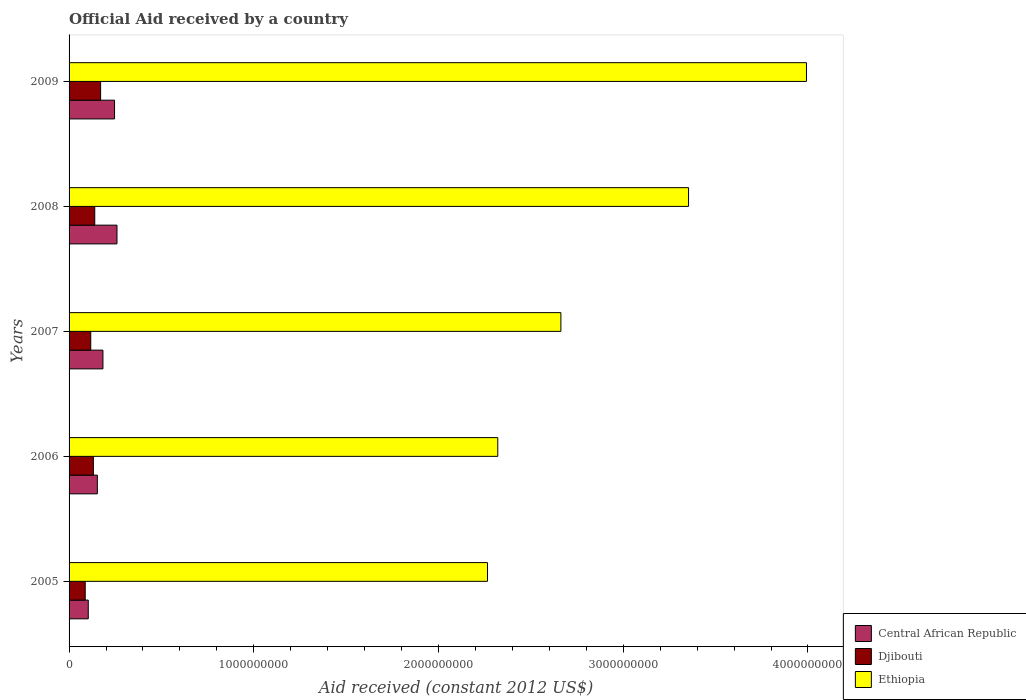Are the number of bars per tick equal to the number of legend labels?
Provide a succinct answer. Yes. How many bars are there on the 3rd tick from the top?
Your answer should be very brief. 3. In how many cases, is the number of bars for a given year not equal to the number of legend labels?
Ensure brevity in your answer.  0. What is the net official aid received in Ethiopia in 2006?
Your response must be concise. 2.32e+09. Across all years, what is the maximum net official aid received in Djibouti?
Keep it short and to the point. 1.71e+08. Across all years, what is the minimum net official aid received in Central African Republic?
Give a very brief answer. 1.04e+08. What is the total net official aid received in Central African Republic in the graph?
Offer a terse response. 9.46e+08. What is the difference between the net official aid received in Djibouti in 2007 and that in 2009?
Provide a succinct answer. -5.34e+07. What is the difference between the net official aid received in Djibouti in 2009 and the net official aid received in Central African Republic in 2007?
Offer a very short reply. -1.25e+07. What is the average net official aid received in Ethiopia per year?
Keep it short and to the point. 2.92e+09. In the year 2008, what is the difference between the net official aid received in Djibouti and net official aid received in Ethiopia?
Offer a very short reply. -3.21e+09. What is the ratio of the net official aid received in Ethiopia in 2007 to that in 2008?
Make the answer very short. 0.79. Is the net official aid received in Ethiopia in 2007 less than that in 2008?
Offer a terse response. Yes. Is the difference between the net official aid received in Djibouti in 2005 and 2008 greater than the difference between the net official aid received in Ethiopia in 2005 and 2008?
Offer a terse response. Yes. What is the difference between the highest and the second highest net official aid received in Ethiopia?
Keep it short and to the point. 6.38e+08. What is the difference between the highest and the lowest net official aid received in Djibouti?
Make the answer very short. 8.34e+07. What does the 3rd bar from the top in 2008 represents?
Your answer should be very brief. Central African Republic. What does the 1st bar from the bottom in 2009 represents?
Provide a succinct answer. Central African Republic. Is it the case that in every year, the sum of the net official aid received in Central African Republic and net official aid received in Ethiopia is greater than the net official aid received in Djibouti?
Provide a succinct answer. Yes. Are all the bars in the graph horizontal?
Offer a very short reply. Yes. Are the values on the major ticks of X-axis written in scientific E-notation?
Your response must be concise. No. Does the graph contain any zero values?
Offer a terse response. No. Does the graph contain grids?
Offer a terse response. No. What is the title of the graph?
Your answer should be compact. Official Aid received by a country. Does "Northern Mariana Islands" appear as one of the legend labels in the graph?
Offer a terse response. No. What is the label or title of the X-axis?
Provide a short and direct response. Aid received (constant 2012 US$). What is the label or title of the Y-axis?
Offer a terse response. Years. What is the Aid received (constant 2012 US$) of Central African Republic in 2005?
Provide a succinct answer. 1.04e+08. What is the Aid received (constant 2012 US$) of Djibouti in 2005?
Give a very brief answer. 8.74e+07. What is the Aid received (constant 2012 US$) of Ethiopia in 2005?
Offer a terse response. 2.27e+09. What is the Aid received (constant 2012 US$) in Central African Republic in 2006?
Provide a short and direct response. 1.53e+08. What is the Aid received (constant 2012 US$) of Djibouti in 2006?
Your response must be concise. 1.32e+08. What is the Aid received (constant 2012 US$) in Ethiopia in 2006?
Your answer should be compact. 2.32e+09. What is the Aid received (constant 2012 US$) of Central African Republic in 2007?
Your response must be concise. 1.83e+08. What is the Aid received (constant 2012 US$) in Djibouti in 2007?
Offer a terse response. 1.17e+08. What is the Aid received (constant 2012 US$) in Ethiopia in 2007?
Your response must be concise. 2.66e+09. What is the Aid received (constant 2012 US$) of Central African Republic in 2008?
Give a very brief answer. 2.59e+08. What is the Aid received (constant 2012 US$) in Djibouti in 2008?
Offer a terse response. 1.39e+08. What is the Aid received (constant 2012 US$) of Ethiopia in 2008?
Your answer should be compact. 3.35e+09. What is the Aid received (constant 2012 US$) in Central African Republic in 2009?
Give a very brief answer. 2.46e+08. What is the Aid received (constant 2012 US$) of Djibouti in 2009?
Offer a terse response. 1.71e+08. What is the Aid received (constant 2012 US$) in Ethiopia in 2009?
Provide a succinct answer. 3.99e+09. Across all years, what is the maximum Aid received (constant 2012 US$) of Central African Republic?
Provide a succinct answer. 2.59e+08. Across all years, what is the maximum Aid received (constant 2012 US$) in Djibouti?
Make the answer very short. 1.71e+08. Across all years, what is the maximum Aid received (constant 2012 US$) in Ethiopia?
Provide a succinct answer. 3.99e+09. Across all years, what is the minimum Aid received (constant 2012 US$) in Central African Republic?
Your answer should be compact. 1.04e+08. Across all years, what is the minimum Aid received (constant 2012 US$) of Djibouti?
Give a very brief answer. 8.74e+07. Across all years, what is the minimum Aid received (constant 2012 US$) of Ethiopia?
Your response must be concise. 2.27e+09. What is the total Aid received (constant 2012 US$) of Central African Republic in the graph?
Your response must be concise. 9.46e+08. What is the total Aid received (constant 2012 US$) in Djibouti in the graph?
Keep it short and to the point. 6.46e+08. What is the total Aid received (constant 2012 US$) in Ethiopia in the graph?
Give a very brief answer. 1.46e+1. What is the difference between the Aid received (constant 2012 US$) of Central African Republic in 2005 and that in 2006?
Offer a terse response. -4.91e+07. What is the difference between the Aid received (constant 2012 US$) in Djibouti in 2005 and that in 2006?
Your answer should be compact. -4.42e+07. What is the difference between the Aid received (constant 2012 US$) in Ethiopia in 2005 and that in 2006?
Provide a short and direct response. -5.56e+07. What is the difference between the Aid received (constant 2012 US$) in Central African Republic in 2005 and that in 2007?
Offer a terse response. -7.94e+07. What is the difference between the Aid received (constant 2012 US$) of Djibouti in 2005 and that in 2007?
Give a very brief answer. -3.00e+07. What is the difference between the Aid received (constant 2012 US$) of Ethiopia in 2005 and that in 2007?
Ensure brevity in your answer.  -3.97e+08. What is the difference between the Aid received (constant 2012 US$) in Central African Republic in 2005 and that in 2008?
Keep it short and to the point. -1.55e+08. What is the difference between the Aid received (constant 2012 US$) in Djibouti in 2005 and that in 2008?
Ensure brevity in your answer.  -5.16e+07. What is the difference between the Aid received (constant 2012 US$) of Ethiopia in 2005 and that in 2008?
Provide a succinct answer. -1.09e+09. What is the difference between the Aid received (constant 2012 US$) of Central African Republic in 2005 and that in 2009?
Your answer should be very brief. -1.42e+08. What is the difference between the Aid received (constant 2012 US$) of Djibouti in 2005 and that in 2009?
Keep it short and to the point. -8.34e+07. What is the difference between the Aid received (constant 2012 US$) of Ethiopia in 2005 and that in 2009?
Offer a very short reply. -1.73e+09. What is the difference between the Aid received (constant 2012 US$) in Central African Republic in 2006 and that in 2007?
Provide a short and direct response. -3.03e+07. What is the difference between the Aid received (constant 2012 US$) in Djibouti in 2006 and that in 2007?
Keep it short and to the point. 1.42e+07. What is the difference between the Aid received (constant 2012 US$) in Ethiopia in 2006 and that in 2007?
Make the answer very short. -3.42e+08. What is the difference between the Aid received (constant 2012 US$) of Central African Republic in 2006 and that in 2008?
Provide a succinct answer. -1.06e+08. What is the difference between the Aid received (constant 2012 US$) of Djibouti in 2006 and that in 2008?
Your answer should be very brief. -7.46e+06. What is the difference between the Aid received (constant 2012 US$) of Ethiopia in 2006 and that in 2008?
Provide a succinct answer. -1.03e+09. What is the difference between the Aid received (constant 2012 US$) of Central African Republic in 2006 and that in 2009?
Your answer should be very brief. -9.32e+07. What is the difference between the Aid received (constant 2012 US$) in Djibouti in 2006 and that in 2009?
Give a very brief answer. -3.92e+07. What is the difference between the Aid received (constant 2012 US$) of Ethiopia in 2006 and that in 2009?
Your answer should be very brief. -1.67e+09. What is the difference between the Aid received (constant 2012 US$) in Central African Republic in 2007 and that in 2008?
Keep it short and to the point. -7.61e+07. What is the difference between the Aid received (constant 2012 US$) of Djibouti in 2007 and that in 2008?
Keep it short and to the point. -2.16e+07. What is the difference between the Aid received (constant 2012 US$) of Ethiopia in 2007 and that in 2008?
Make the answer very short. -6.91e+08. What is the difference between the Aid received (constant 2012 US$) of Central African Republic in 2007 and that in 2009?
Offer a terse response. -6.29e+07. What is the difference between the Aid received (constant 2012 US$) in Djibouti in 2007 and that in 2009?
Offer a very short reply. -5.34e+07. What is the difference between the Aid received (constant 2012 US$) in Ethiopia in 2007 and that in 2009?
Ensure brevity in your answer.  -1.33e+09. What is the difference between the Aid received (constant 2012 US$) in Central African Republic in 2008 and that in 2009?
Offer a terse response. 1.32e+07. What is the difference between the Aid received (constant 2012 US$) in Djibouti in 2008 and that in 2009?
Keep it short and to the point. -3.17e+07. What is the difference between the Aid received (constant 2012 US$) of Ethiopia in 2008 and that in 2009?
Your response must be concise. -6.38e+08. What is the difference between the Aid received (constant 2012 US$) in Central African Republic in 2005 and the Aid received (constant 2012 US$) in Djibouti in 2006?
Ensure brevity in your answer.  -2.76e+07. What is the difference between the Aid received (constant 2012 US$) of Central African Republic in 2005 and the Aid received (constant 2012 US$) of Ethiopia in 2006?
Your response must be concise. -2.22e+09. What is the difference between the Aid received (constant 2012 US$) in Djibouti in 2005 and the Aid received (constant 2012 US$) in Ethiopia in 2006?
Offer a very short reply. -2.23e+09. What is the difference between the Aid received (constant 2012 US$) of Central African Republic in 2005 and the Aid received (constant 2012 US$) of Djibouti in 2007?
Offer a terse response. -1.34e+07. What is the difference between the Aid received (constant 2012 US$) in Central African Republic in 2005 and the Aid received (constant 2012 US$) in Ethiopia in 2007?
Provide a short and direct response. -2.56e+09. What is the difference between the Aid received (constant 2012 US$) of Djibouti in 2005 and the Aid received (constant 2012 US$) of Ethiopia in 2007?
Your response must be concise. -2.58e+09. What is the difference between the Aid received (constant 2012 US$) in Central African Republic in 2005 and the Aid received (constant 2012 US$) in Djibouti in 2008?
Ensure brevity in your answer.  -3.51e+07. What is the difference between the Aid received (constant 2012 US$) of Central African Republic in 2005 and the Aid received (constant 2012 US$) of Ethiopia in 2008?
Your answer should be compact. -3.25e+09. What is the difference between the Aid received (constant 2012 US$) of Djibouti in 2005 and the Aid received (constant 2012 US$) of Ethiopia in 2008?
Provide a succinct answer. -3.27e+09. What is the difference between the Aid received (constant 2012 US$) of Central African Republic in 2005 and the Aid received (constant 2012 US$) of Djibouti in 2009?
Your answer should be very brief. -6.68e+07. What is the difference between the Aid received (constant 2012 US$) in Central African Republic in 2005 and the Aid received (constant 2012 US$) in Ethiopia in 2009?
Provide a succinct answer. -3.89e+09. What is the difference between the Aid received (constant 2012 US$) of Djibouti in 2005 and the Aid received (constant 2012 US$) of Ethiopia in 2009?
Provide a succinct answer. -3.90e+09. What is the difference between the Aid received (constant 2012 US$) of Central African Republic in 2006 and the Aid received (constant 2012 US$) of Djibouti in 2007?
Provide a short and direct response. 3.56e+07. What is the difference between the Aid received (constant 2012 US$) of Central African Republic in 2006 and the Aid received (constant 2012 US$) of Ethiopia in 2007?
Provide a short and direct response. -2.51e+09. What is the difference between the Aid received (constant 2012 US$) of Djibouti in 2006 and the Aid received (constant 2012 US$) of Ethiopia in 2007?
Your response must be concise. -2.53e+09. What is the difference between the Aid received (constant 2012 US$) of Central African Republic in 2006 and the Aid received (constant 2012 US$) of Djibouti in 2008?
Your answer should be compact. 1.40e+07. What is the difference between the Aid received (constant 2012 US$) of Central African Republic in 2006 and the Aid received (constant 2012 US$) of Ethiopia in 2008?
Make the answer very short. -3.20e+09. What is the difference between the Aid received (constant 2012 US$) in Djibouti in 2006 and the Aid received (constant 2012 US$) in Ethiopia in 2008?
Keep it short and to the point. -3.22e+09. What is the difference between the Aid received (constant 2012 US$) in Central African Republic in 2006 and the Aid received (constant 2012 US$) in Djibouti in 2009?
Provide a succinct answer. -1.78e+07. What is the difference between the Aid received (constant 2012 US$) in Central African Republic in 2006 and the Aid received (constant 2012 US$) in Ethiopia in 2009?
Keep it short and to the point. -3.84e+09. What is the difference between the Aid received (constant 2012 US$) in Djibouti in 2006 and the Aid received (constant 2012 US$) in Ethiopia in 2009?
Make the answer very short. -3.86e+09. What is the difference between the Aid received (constant 2012 US$) of Central African Republic in 2007 and the Aid received (constant 2012 US$) of Djibouti in 2008?
Your answer should be compact. 4.43e+07. What is the difference between the Aid received (constant 2012 US$) of Central African Republic in 2007 and the Aid received (constant 2012 US$) of Ethiopia in 2008?
Keep it short and to the point. -3.17e+09. What is the difference between the Aid received (constant 2012 US$) of Djibouti in 2007 and the Aid received (constant 2012 US$) of Ethiopia in 2008?
Offer a terse response. -3.24e+09. What is the difference between the Aid received (constant 2012 US$) in Central African Republic in 2007 and the Aid received (constant 2012 US$) in Djibouti in 2009?
Offer a terse response. 1.25e+07. What is the difference between the Aid received (constant 2012 US$) of Central African Republic in 2007 and the Aid received (constant 2012 US$) of Ethiopia in 2009?
Ensure brevity in your answer.  -3.81e+09. What is the difference between the Aid received (constant 2012 US$) of Djibouti in 2007 and the Aid received (constant 2012 US$) of Ethiopia in 2009?
Offer a very short reply. -3.87e+09. What is the difference between the Aid received (constant 2012 US$) of Central African Republic in 2008 and the Aid received (constant 2012 US$) of Djibouti in 2009?
Make the answer very short. 8.86e+07. What is the difference between the Aid received (constant 2012 US$) in Central African Republic in 2008 and the Aid received (constant 2012 US$) in Ethiopia in 2009?
Your response must be concise. -3.73e+09. What is the difference between the Aid received (constant 2012 US$) of Djibouti in 2008 and the Aid received (constant 2012 US$) of Ethiopia in 2009?
Keep it short and to the point. -3.85e+09. What is the average Aid received (constant 2012 US$) in Central African Republic per year?
Ensure brevity in your answer.  1.89e+08. What is the average Aid received (constant 2012 US$) of Djibouti per year?
Your response must be concise. 1.29e+08. What is the average Aid received (constant 2012 US$) of Ethiopia per year?
Give a very brief answer. 2.92e+09. In the year 2005, what is the difference between the Aid received (constant 2012 US$) of Central African Republic and Aid received (constant 2012 US$) of Djibouti?
Ensure brevity in your answer.  1.66e+07. In the year 2005, what is the difference between the Aid received (constant 2012 US$) of Central African Republic and Aid received (constant 2012 US$) of Ethiopia?
Ensure brevity in your answer.  -2.16e+09. In the year 2005, what is the difference between the Aid received (constant 2012 US$) of Djibouti and Aid received (constant 2012 US$) of Ethiopia?
Your answer should be very brief. -2.18e+09. In the year 2006, what is the difference between the Aid received (constant 2012 US$) of Central African Republic and Aid received (constant 2012 US$) of Djibouti?
Your answer should be very brief. 2.14e+07. In the year 2006, what is the difference between the Aid received (constant 2012 US$) of Central African Republic and Aid received (constant 2012 US$) of Ethiopia?
Offer a terse response. -2.17e+09. In the year 2006, what is the difference between the Aid received (constant 2012 US$) of Djibouti and Aid received (constant 2012 US$) of Ethiopia?
Offer a very short reply. -2.19e+09. In the year 2007, what is the difference between the Aid received (constant 2012 US$) of Central African Republic and Aid received (constant 2012 US$) of Djibouti?
Provide a short and direct response. 6.59e+07. In the year 2007, what is the difference between the Aid received (constant 2012 US$) in Central African Republic and Aid received (constant 2012 US$) in Ethiopia?
Your answer should be very brief. -2.48e+09. In the year 2007, what is the difference between the Aid received (constant 2012 US$) of Djibouti and Aid received (constant 2012 US$) of Ethiopia?
Provide a short and direct response. -2.55e+09. In the year 2008, what is the difference between the Aid received (constant 2012 US$) of Central African Republic and Aid received (constant 2012 US$) of Djibouti?
Provide a short and direct response. 1.20e+08. In the year 2008, what is the difference between the Aid received (constant 2012 US$) of Central African Republic and Aid received (constant 2012 US$) of Ethiopia?
Your response must be concise. -3.09e+09. In the year 2008, what is the difference between the Aid received (constant 2012 US$) in Djibouti and Aid received (constant 2012 US$) in Ethiopia?
Your response must be concise. -3.21e+09. In the year 2009, what is the difference between the Aid received (constant 2012 US$) of Central African Republic and Aid received (constant 2012 US$) of Djibouti?
Offer a very short reply. 7.54e+07. In the year 2009, what is the difference between the Aid received (constant 2012 US$) of Central African Republic and Aid received (constant 2012 US$) of Ethiopia?
Your answer should be compact. -3.75e+09. In the year 2009, what is the difference between the Aid received (constant 2012 US$) in Djibouti and Aid received (constant 2012 US$) in Ethiopia?
Provide a short and direct response. -3.82e+09. What is the ratio of the Aid received (constant 2012 US$) in Central African Republic in 2005 to that in 2006?
Ensure brevity in your answer.  0.68. What is the ratio of the Aid received (constant 2012 US$) in Djibouti in 2005 to that in 2006?
Offer a terse response. 0.66. What is the ratio of the Aid received (constant 2012 US$) of Ethiopia in 2005 to that in 2006?
Your answer should be compact. 0.98. What is the ratio of the Aid received (constant 2012 US$) in Central African Republic in 2005 to that in 2007?
Offer a terse response. 0.57. What is the ratio of the Aid received (constant 2012 US$) of Djibouti in 2005 to that in 2007?
Keep it short and to the point. 0.74. What is the ratio of the Aid received (constant 2012 US$) of Ethiopia in 2005 to that in 2007?
Offer a terse response. 0.85. What is the ratio of the Aid received (constant 2012 US$) of Central African Republic in 2005 to that in 2008?
Offer a terse response. 0.4. What is the ratio of the Aid received (constant 2012 US$) of Djibouti in 2005 to that in 2008?
Make the answer very short. 0.63. What is the ratio of the Aid received (constant 2012 US$) of Ethiopia in 2005 to that in 2008?
Give a very brief answer. 0.68. What is the ratio of the Aid received (constant 2012 US$) in Central African Republic in 2005 to that in 2009?
Your response must be concise. 0.42. What is the ratio of the Aid received (constant 2012 US$) of Djibouti in 2005 to that in 2009?
Keep it short and to the point. 0.51. What is the ratio of the Aid received (constant 2012 US$) of Ethiopia in 2005 to that in 2009?
Give a very brief answer. 0.57. What is the ratio of the Aid received (constant 2012 US$) of Central African Republic in 2006 to that in 2007?
Your answer should be very brief. 0.83. What is the ratio of the Aid received (constant 2012 US$) of Djibouti in 2006 to that in 2007?
Your answer should be very brief. 1.12. What is the ratio of the Aid received (constant 2012 US$) in Ethiopia in 2006 to that in 2007?
Ensure brevity in your answer.  0.87. What is the ratio of the Aid received (constant 2012 US$) in Central African Republic in 2006 to that in 2008?
Provide a succinct answer. 0.59. What is the ratio of the Aid received (constant 2012 US$) of Djibouti in 2006 to that in 2008?
Offer a very short reply. 0.95. What is the ratio of the Aid received (constant 2012 US$) in Ethiopia in 2006 to that in 2008?
Provide a short and direct response. 0.69. What is the ratio of the Aid received (constant 2012 US$) in Central African Republic in 2006 to that in 2009?
Your response must be concise. 0.62. What is the ratio of the Aid received (constant 2012 US$) in Djibouti in 2006 to that in 2009?
Ensure brevity in your answer.  0.77. What is the ratio of the Aid received (constant 2012 US$) of Ethiopia in 2006 to that in 2009?
Make the answer very short. 0.58. What is the ratio of the Aid received (constant 2012 US$) in Central African Republic in 2007 to that in 2008?
Your answer should be compact. 0.71. What is the ratio of the Aid received (constant 2012 US$) of Djibouti in 2007 to that in 2008?
Ensure brevity in your answer.  0.84. What is the ratio of the Aid received (constant 2012 US$) in Ethiopia in 2007 to that in 2008?
Your response must be concise. 0.79. What is the ratio of the Aid received (constant 2012 US$) of Central African Republic in 2007 to that in 2009?
Give a very brief answer. 0.74. What is the ratio of the Aid received (constant 2012 US$) of Djibouti in 2007 to that in 2009?
Provide a succinct answer. 0.69. What is the ratio of the Aid received (constant 2012 US$) of Ethiopia in 2007 to that in 2009?
Keep it short and to the point. 0.67. What is the ratio of the Aid received (constant 2012 US$) of Central African Republic in 2008 to that in 2009?
Your answer should be compact. 1.05. What is the ratio of the Aid received (constant 2012 US$) of Djibouti in 2008 to that in 2009?
Your answer should be compact. 0.81. What is the ratio of the Aid received (constant 2012 US$) of Ethiopia in 2008 to that in 2009?
Give a very brief answer. 0.84. What is the difference between the highest and the second highest Aid received (constant 2012 US$) of Central African Republic?
Your response must be concise. 1.32e+07. What is the difference between the highest and the second highest Aid received (constant 2012 US$) of Djibouti?
Offer a very short reply. 3.17e+07. What is the difference between the highest and the second highest Aid received (constant 2012 US$) in Ethiopia?
Your answer should be compact. 6.38e+08. What is the difference between the highest and the lowest Aid received (constant 2012 US$) in Central African Republic?
Provide a short and direct response. 1.55e+08. What is the difference between the highest and the lowest Aid received (constant 2012 US$) of Djibouti?
Your answer should be compact. 8.34e+07. What is the difference between the highest and the lowest Aid received (constant 2012 US$) in Ethiopia?
Provide a succinct answer. 1.73e+09. 